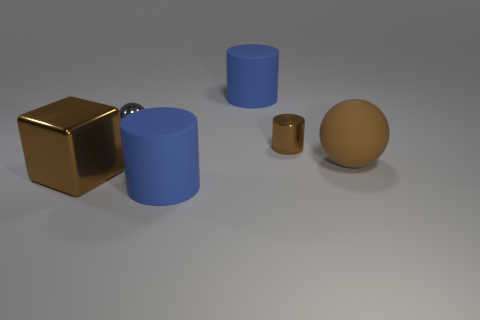Add 4 tiny gray objects. How many objects exist? 10 Subtract all cubes. How many objects are left? 5 Subtract 0 yellow cubes. How many objects are left? 6 Subtract all large brown matte balls. Subtract all metal cylinders. How many objects are left? 4 Add 1 rubber cylinders. How many rubber cylinders are left? 3 Add 4 large yellow rubber cylinders. How many large yellow rubber cylinders exist? 4 